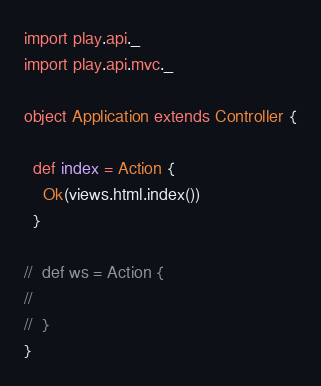<code> <loc_0><loc_0><loc_500><loc_500><_Scala_>
import play.api._
import play.api.mvc._

object Application extends Controller {

  def index = Action {
    Ok(views.html.index())
  }

//  def ws = Action {
//
//  }
}</code> 